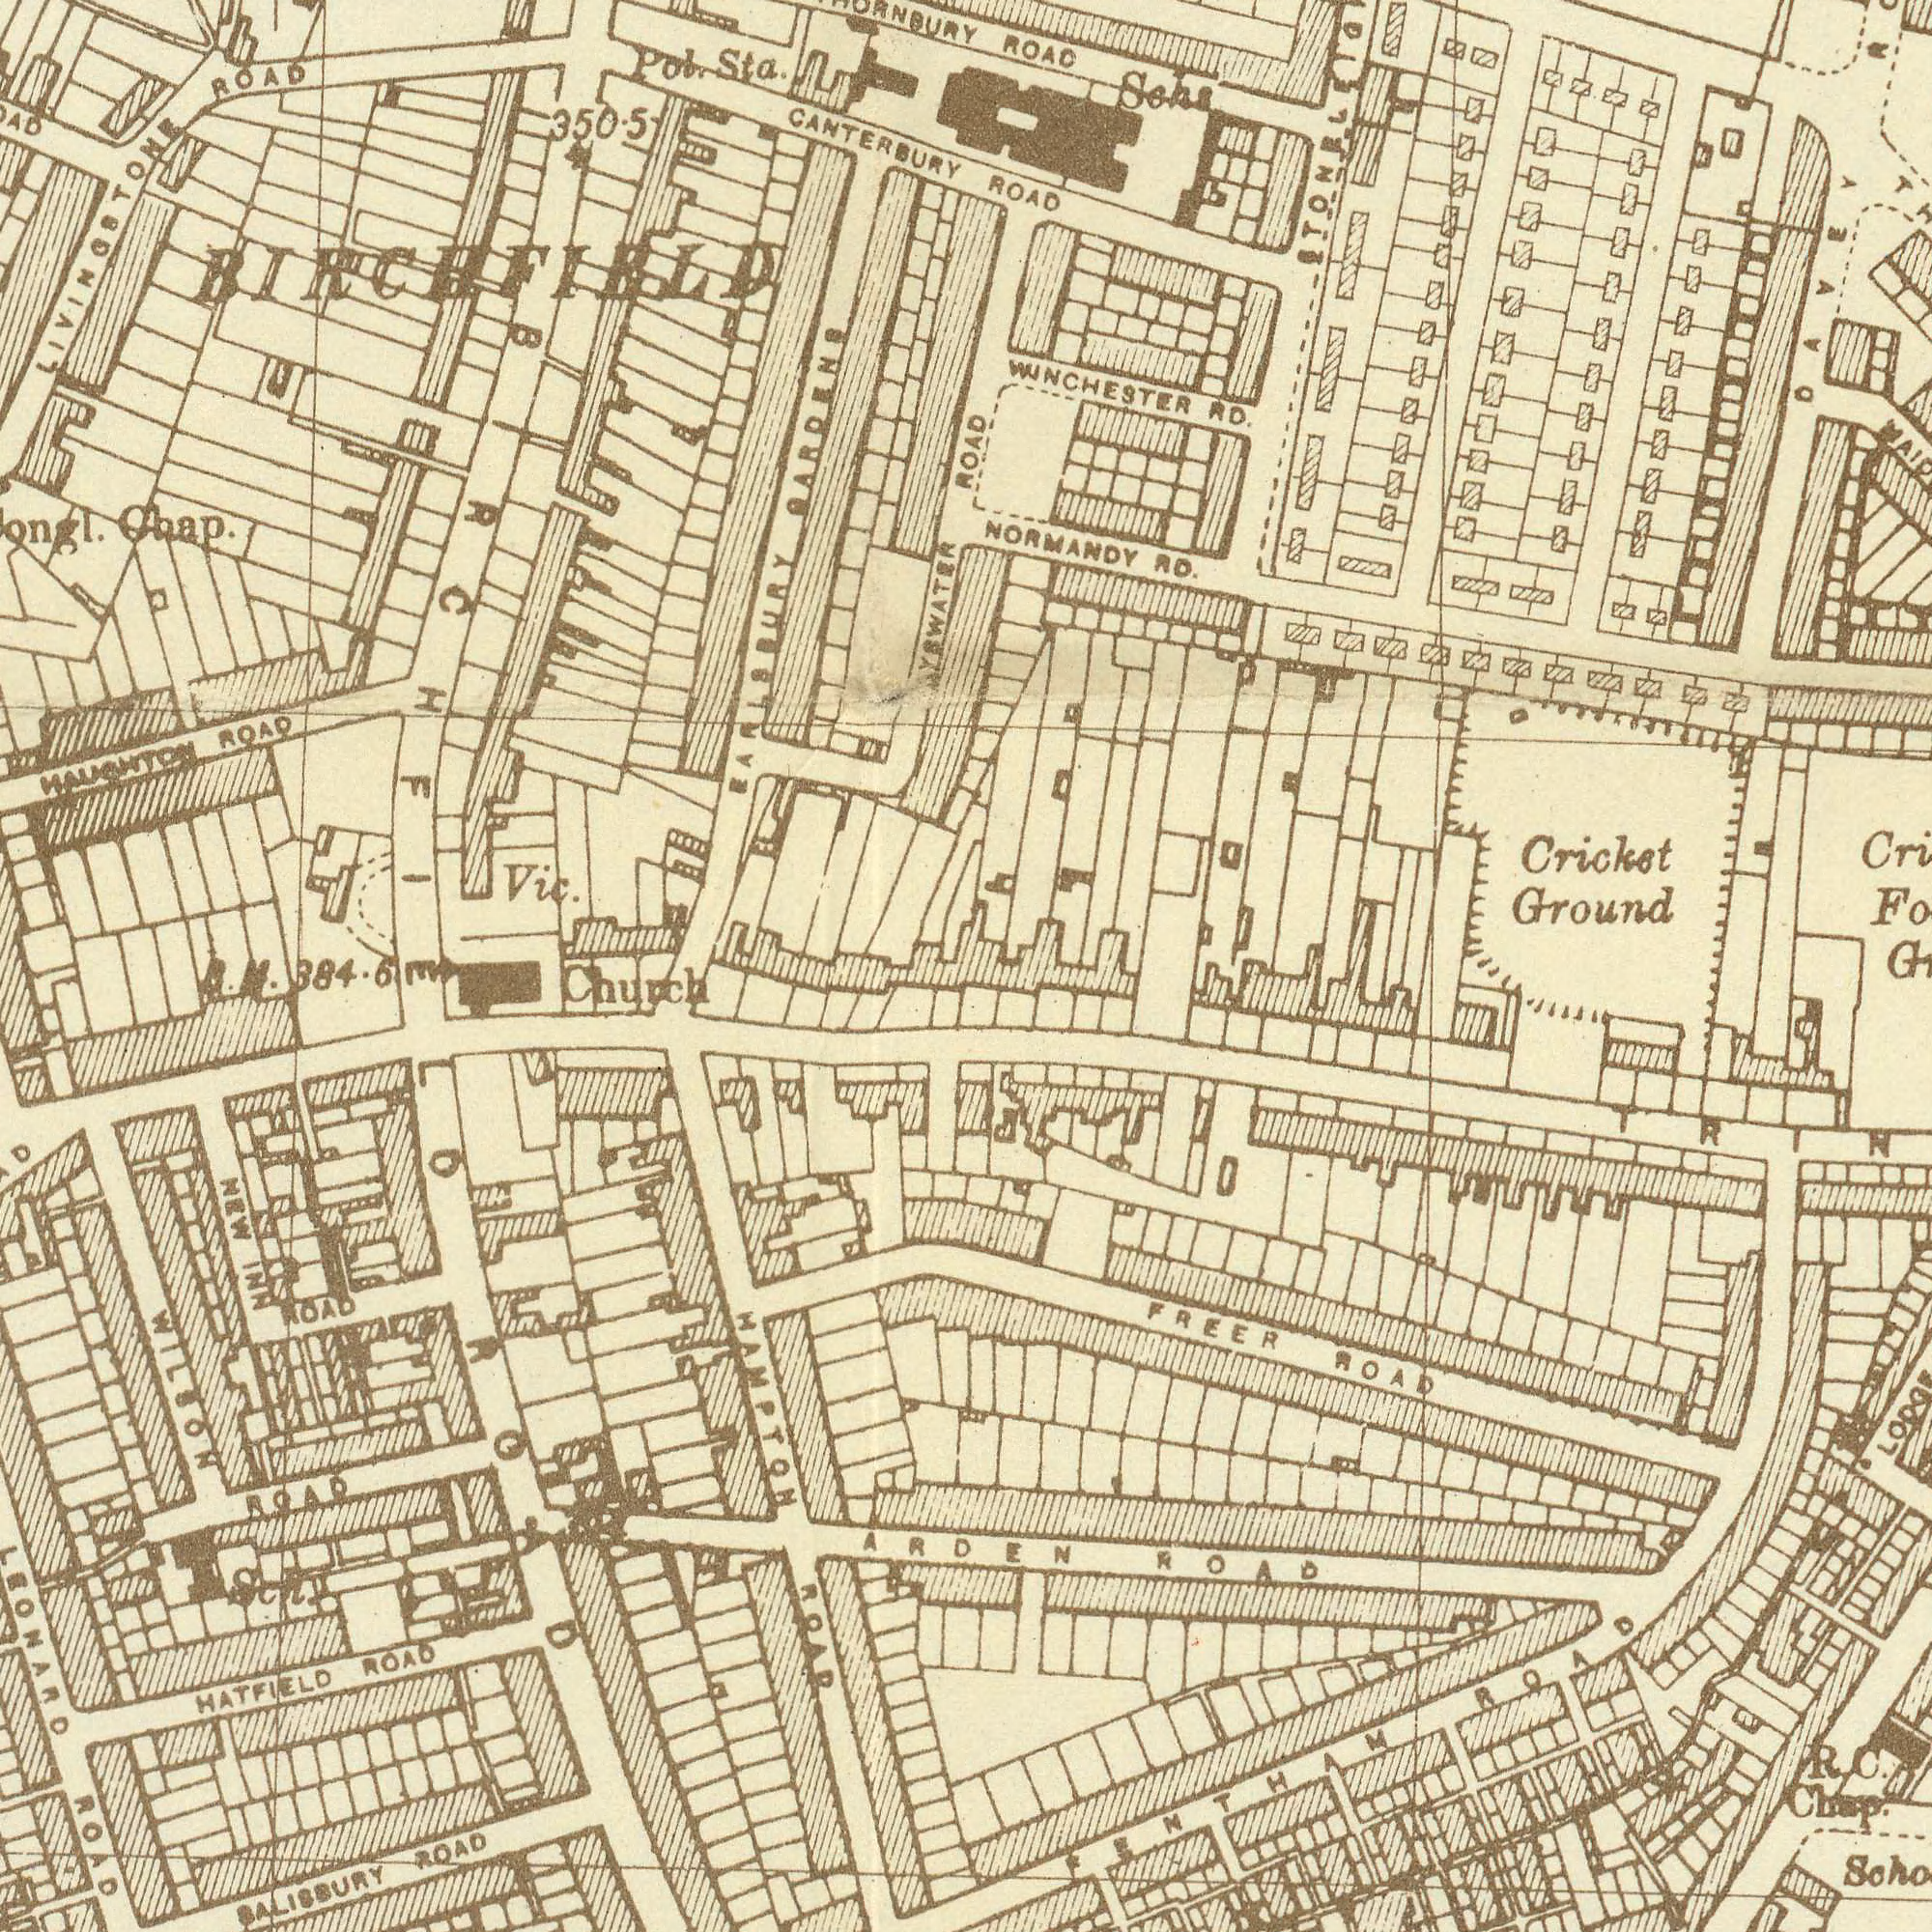What text is visible in the lower-left corner? HATFIELD ROAD HAMPTON ROAD NEW INN ROAD Church SALISBURY ROAD WILSON ROAD LEONARD ROAD ROAD Sch What text appears in the bottom-right area of the image? FREER ROAD ARDEN ROAD FENTHAM ROAD R. C. Chap. LODGE What text can you see in the top-right section? ROAD NORMANDY RD. Cricket Ground ROAC DAVEY WINCHESTER RD. SChs ROAD What text can you see in the top-left section? CANTERBURY Vic. HAUGHTON ROAD LIVINGSTONE ROAD Pol. Sta. Chap. EARLSBURY GARDENS 350.5 BIRCHFIELD B. M. 384.6 BAYSWATER BIRCHFIELD 